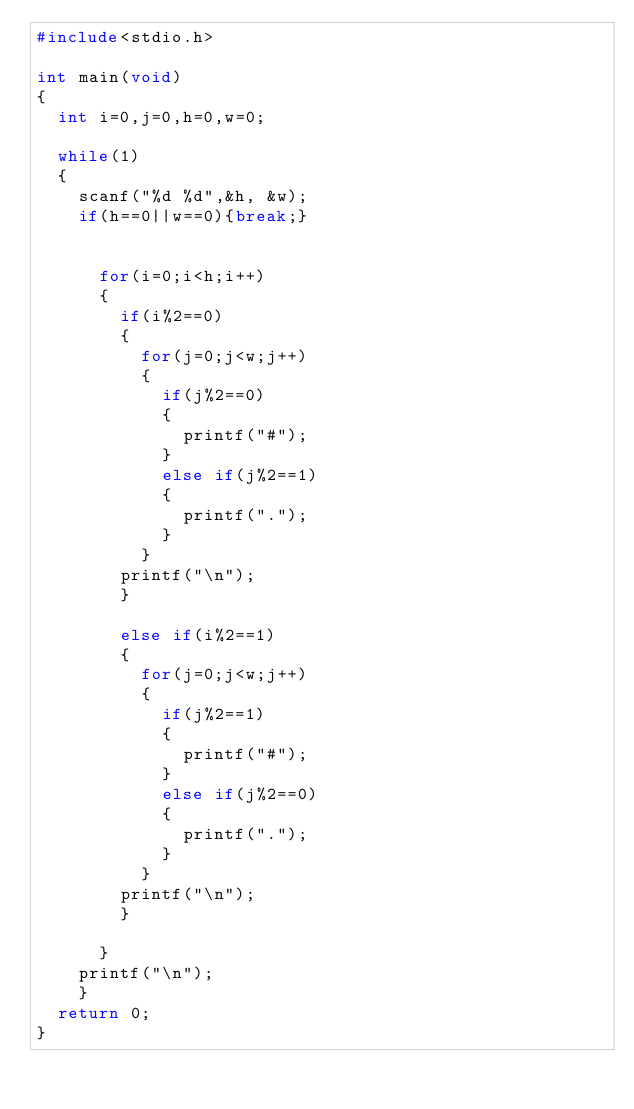<code> <loc_0><loc_0><loc_500><loc_500><_C_>#include<stdio.h>

int main(void)
{
	int i=0,j=0,h=0,w=0;
	
	while(1)
	{
		scanf("%d %d",&h, &w);
		if(h==0||w==0){break;}
		

			for(i=0;i<h;i++)
			{
				if(i%2==0)
				{
					for(j=0;j<w;j++)
					{
						if(j%2==0)
						{
							printf("#");
						}
						else if(j%2==1)
						{
							printf(".");
						}
					}
				printf("\n");
				}
				
				else if(i%2==1)
				{
					for(j=0;j<w;j++)
					{
						if(j%2==1)
						{
							printf("#");
						}
						else if(j%2==0)
						{
							printf(".");
						}
					}
				printf("\n");
				}
		
			}
		printf("\n");
		}
	return 0;
}</code> 